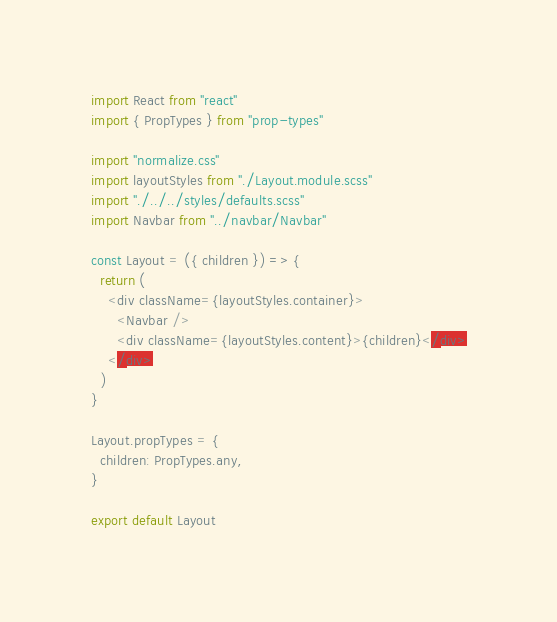<code> <loc_0><loc_0><loc_500><loc_500><_JavaScript_>import React from "react"
import { PropTypes } from "prop-types"

import "normalize.css"
import layoutStyles from "./Layout.module.scss"
import "./../../styles/defaults.scss"
import Navbar from "../navbar/Navbar"

const Layout = ({ children }) => {
  return (
    <div className={layoutStyles.container}>
      <Navbar />
      <div className={layoutStyles.content}>{children}</div>
    </div>
  )
}

Layout.propTypes = {
  children: PropTypes.any,
}

export default Layout
</code> 